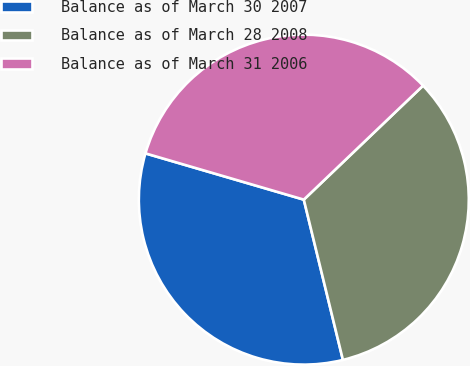Convert chart. <chart><loc_0><loc_0><loc_500><loc_500><pie_chart><fcel>Balance as of March 30 2007<fcel>Balance as of March 28 2008<fcel>Balance as of March 31 2006<nl><fcel>33.33%<fcel>33.33%<fcel>33.33%<nl></chart> 